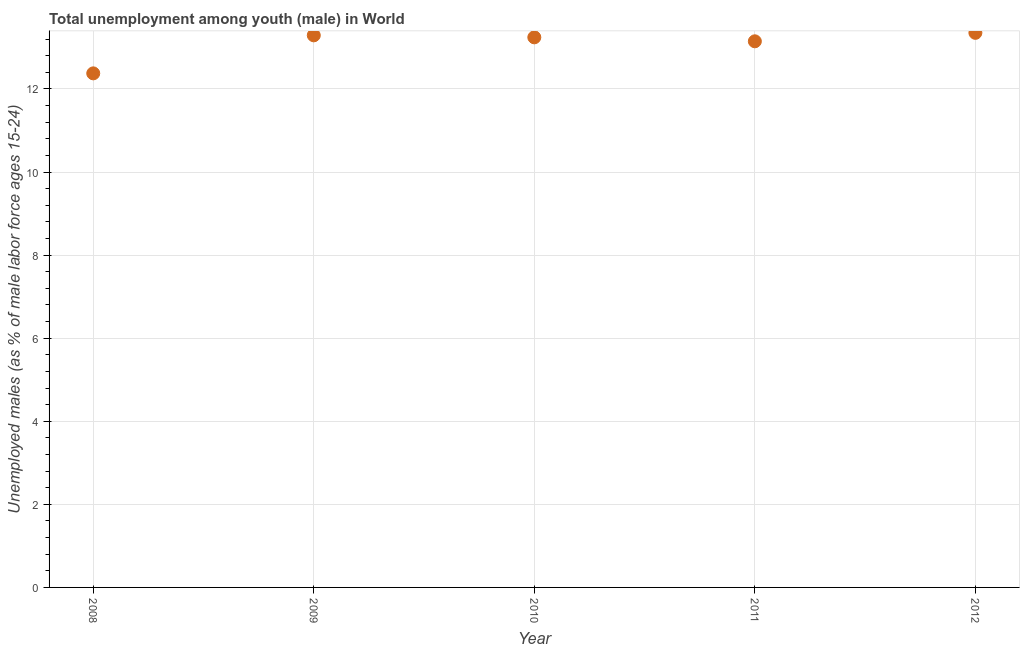What is the unemployed male youth population in 2011?
Offer a terse response. 13.15. Across all years, what is the maximum unemployed male youth population?
Offer a terse response. 13.35. Across all years, what is the minimum unemployed male youth population?
Keep it short and to the point. 12.37. In which year was the unemployed male youth population maximum?
Provide a succinct answer. 2012. In which year was the unemployed male youth population minimum?
Keep it short and to the point. 2008. What is the sum of the unemployed male youth population?
Your answer should be very brief. 65.4. What is the difference between the unemployed male youth population in 2009 and 2011?
Offer a terse response. 0.14. What is the average unemployed male youth population per year?
Your response must be concise. 13.08. What is the median unemployed male youth population?
Your response must be concise. 13.24. What is the ratio of the unemployed male youth population in 2011 to that in 2012?
Keep it short and to the point. 0.98. What is the difference between the highest and the second highest unemployed male youth population?
Your answer should be very brief. 0.06. What is the difference between the highest and the lowest unemployed male youth population?
Provide a succinct answer. 0.98. In how many years, is the unemployed male youth population greater than the average unemployed male youth population taken over all years?
Provide a succinct answer. 4. Does the unemployed male youth population monotonically increase over the years?
Offer a terse response. No. What is the difference between two consecutive major ticks on the Y-axis?
Make the answer very short. 2. Are the values on the major ticks of Y-axis written in scientific E-notation?
Your answer should be compact. No. Does the graph contain any zero values?
Give a very brief answer. No. Does the graph contain grids?
Your answer should be compact. Yes. What is the title of the graph?
Keep it short and to the point. Total unemployment among youth (male) in World. What is the label or title of the X-axis?
Ensure brevity in your answer.  Year. What is the label or title of the Y-axis?
Your answer should be very brief. Unemployed males (as % of male labor force ages 15-24). What is the Unemployed males (as % of male labor force ages 15-24) in 2008?
Provide a short and direct response. 12.37. What is the Unemployed males (as % of male labor force ages 15-24) in 2009?
Give a very brief answer. 13.29. What is the Unemployed males (as % of male labor force ages 15-24) in 2010?
Offer a terse response. 13.24. What is the Unemployed males (as % of male labor force ages 15-24) in 2011?
Make the answer very short. 13.15. What is the Unemployed males (as % of male labor force ages 15-24) in 2012?
Your response must be concise. 13.35. What is the difference between the Unemployed males (as % of male labor force ages 15-24) in 2008 and 2009?
Offer a terse response. -0.92. What is the difference between the Unemployed males (as % of male labor force ages 15-24) in 2008 and 2010?
Your answer should be very brief. -0.87. What is the difference between the Unemployed males (as % of male labor force ages 15-24) in 2008 and 2011?
Your answer should be compact. -0.77. What is the difference between the Unemployed males (as % of male labor force ages 15-24) in 2008 and 2012?
Your answer should be compact. -0.98. What is the difference between the Unemployed males (as % of male labor force ages 15-24) in 2009 and 2010?
Offer a terse response. 0.05. What is the difference between the Unemployed males (as % of male labor force ages 15-24) in 2009 and 2011?
Your answer should be compact. 0.14. What is the difference between the Unemployed males (as % of male labor force ages 15-24) in 2009 and 2012?
Provide a short and direct response. -0.06. What is the difference between the Unemployed males (as % of male labor force ages 15-24) in 2010 and 2011?
Your answer should be very brief. 0.1. What is the difference between the Unemployed males (as % of male labor force ages 15-24) in 2010 and 2012?
Offer a very short reply. -0.11. What is the difference between the Unemployed males (as % of male labor force ages 15-24) in 2011 and 2012?
Make the answer very short. -0.2. What is the ratio of the Unemployed males (as % of male labor force ages 15-24) in 2008 to that in 2010?
Provide a succinct answer. 0.94. What is the ratio of the Unemployed males (as % of male labor force ages 15-24) in 2008 to that in 2011?
Make the answer very short. 0.94. What is the ratio of the Unemployed males (as % of male labor force ages 15-24) in 2008 to that in 2012?
Provide a short and direct response. 0.93. What is the ratio of the Unemployed males (as % of male labor force ages 15-24) in 2009 to that in 2011?
Your response must be concise. 1.01. What is the ratio of the Unemployed males (as % of male labor force ages 15-24) in 2010 to that in 2011?
Provide a succinct answer. 1.01. 